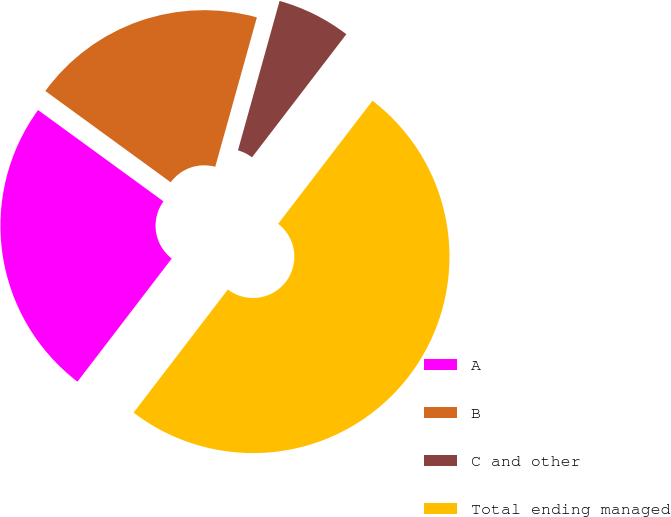<chart> <loc_0><loc_0><loc_500><loc_500><pie_chart><fcel>A<fcel>B<fcel>C and other<fcel>Total ending managed<nl><fcel>24.62%<fcel>19.31%<fcel>6.08%<fcel>50.0%<nl></chart> 